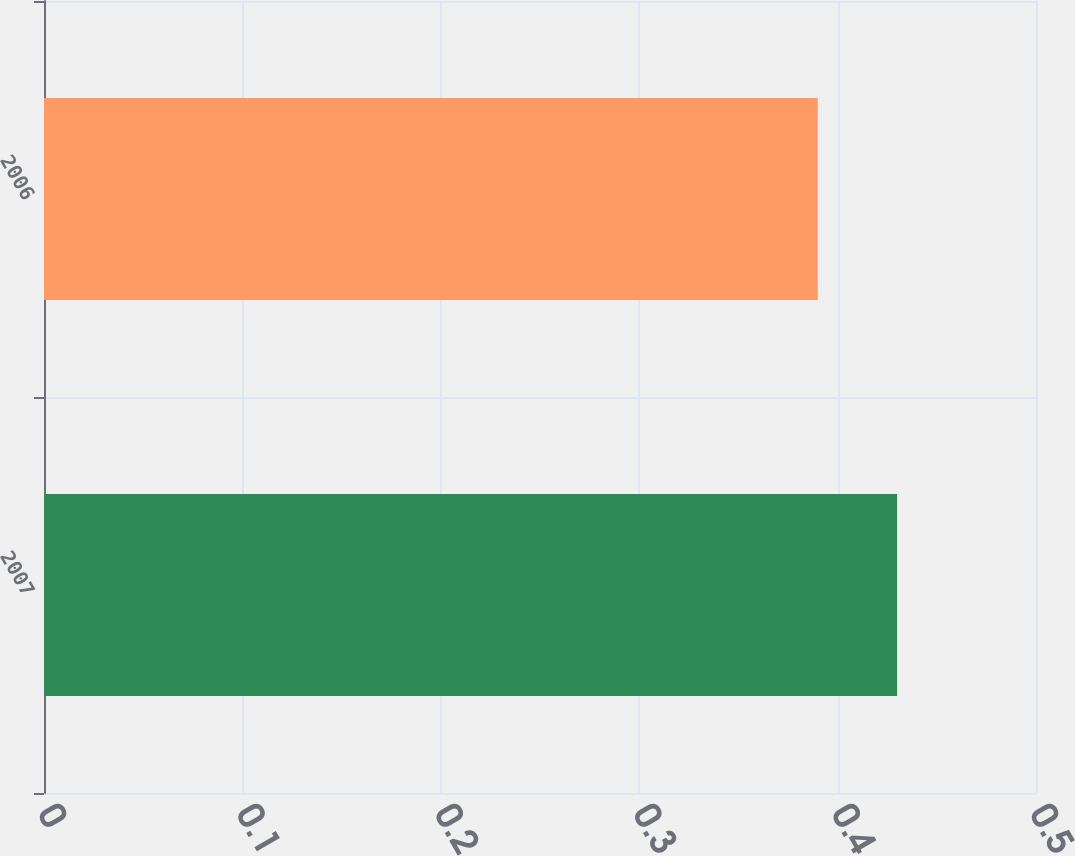<chart> <loc_0><loc_0><loc_500><loc_500><bar_chart><fcel>2007<fcel>2006<nl><fcel>0.43<fcel>0.39<nl></chart> 